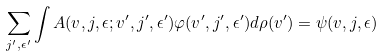Convert formula to latex. <formula><loc_0><loc_0><loc_500><loc_500>\sum _ { j ^ { \prime } , \epsilon ^ { \prime } } \int A ( { v } , j , \epsilon ; { v } ^ { \prime } , j ^ { \prime } , \epsilon ^ { \prime } ) \varphi ( { v } ^ { \prime } , j ^ { \prime } , \epsilon ^ { \prime } ) d \rho ( { v } ^ { \prime } ) = \psi ( { v } , j , \epsilon )</formula> 